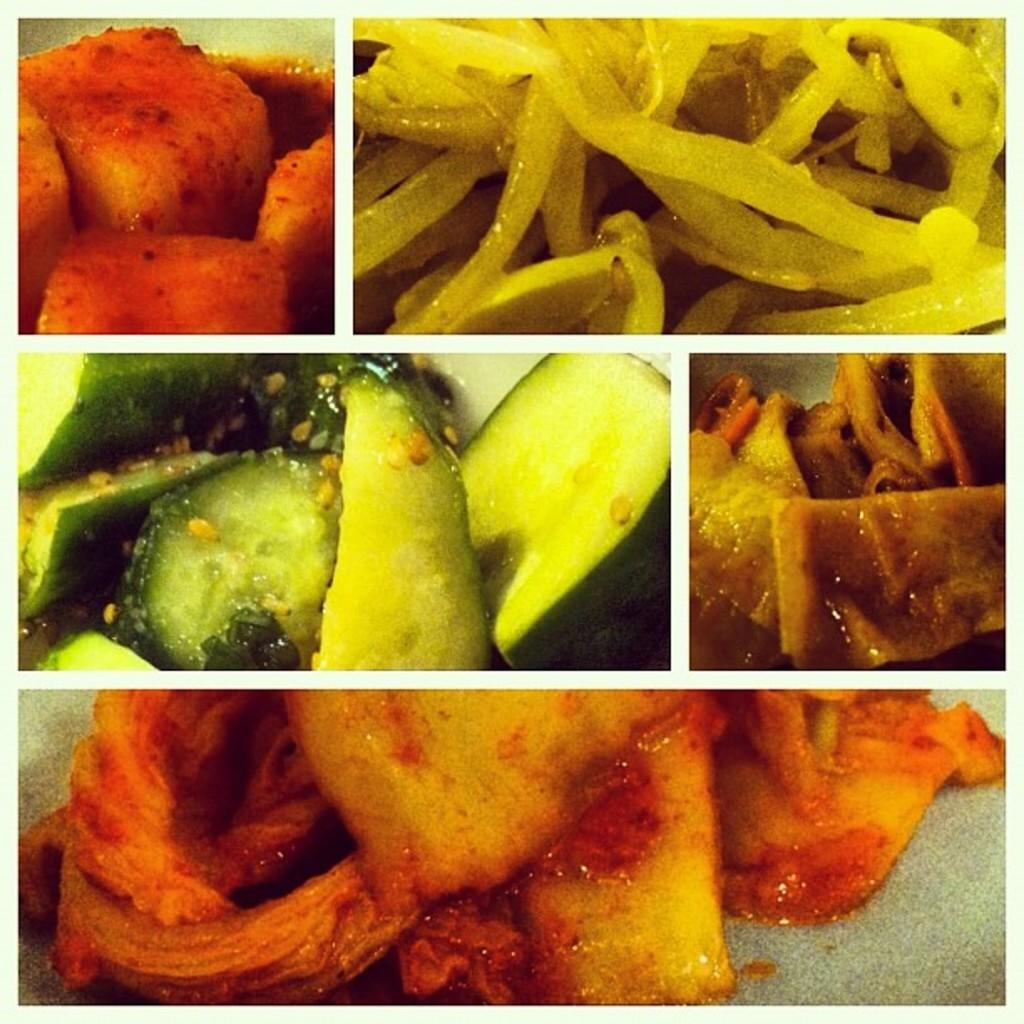What type of amusement can be seen at the zoo in the image? There is no information about a zoo or amusement in the image, so it is not possible to answer that question. 